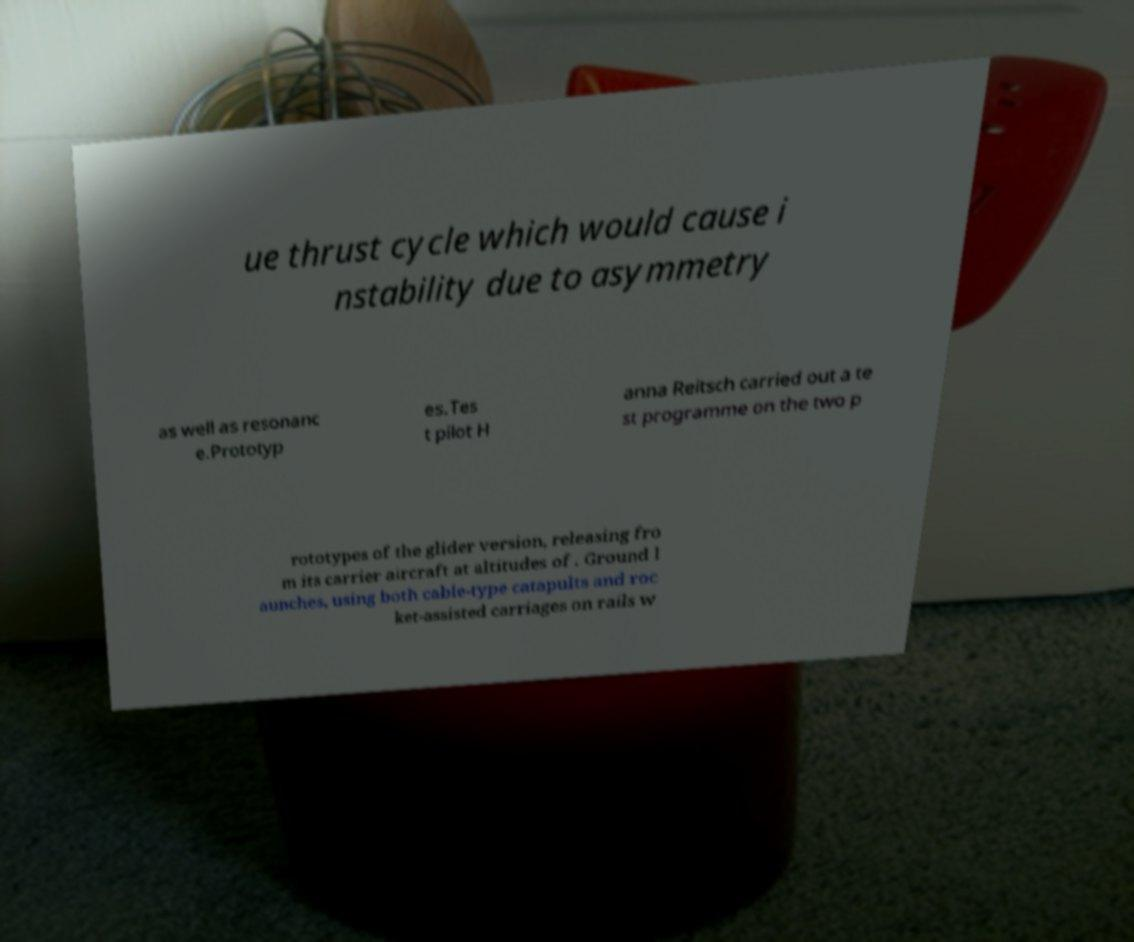What messages or text are displayed in this image? I need them in a readable, typed format. ue thrust cycle which would cause i nstability due to asymmetry as well as resonanc e.Prototyp es.Tes t pilot H anna Reitsch carried out a te st programme on the two p rototypes of the glider version, releasing fro m its carrier aircraft at altitudes of . Ground l aunches, using both cable-type catapults and roc ket-assisted carriages on rails w 